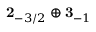<formula> <loc_0><loc_0><loc_500><loc_500>2 _ { - 3 / 2 } \oplus 3 _ { - 1 }</formula> 